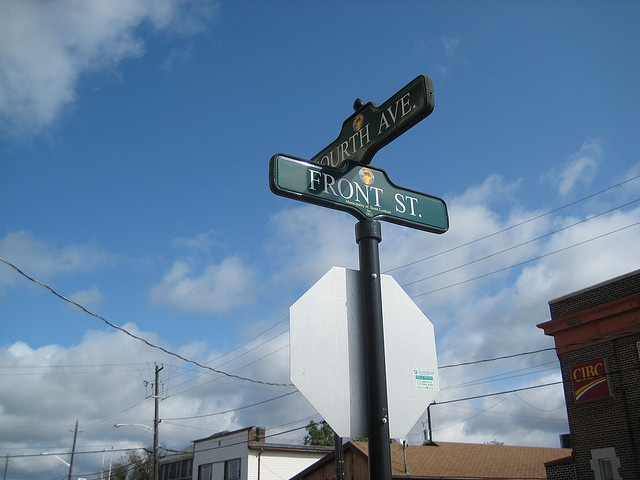Describe the objects in this image and their specific colors. I can see a stop sign in gray, lightgray, darkgray, and black tones in this image. 